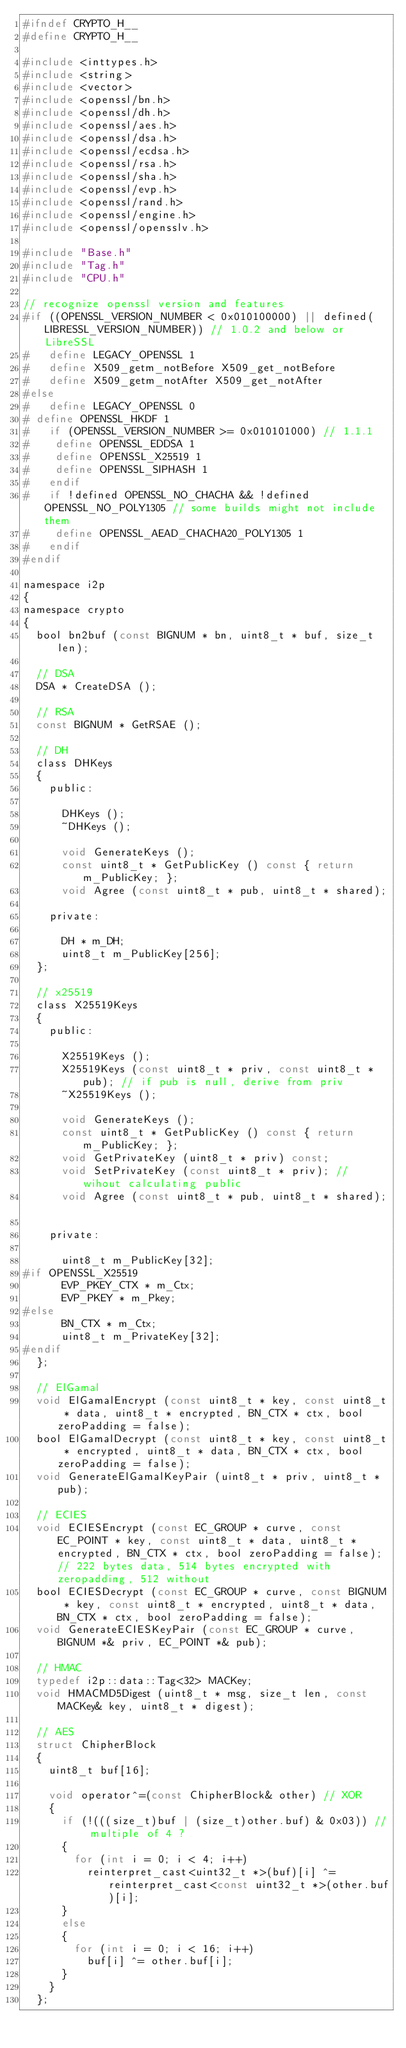Convert code to text. <code><loc_0><loc_0><loc_500><loc_500><_C_>#ifndef CRYPTO_H__
#define CRYPTO_H__

#include <inttypes.h>
#include <string>
#include <vector>
#include <openssl/bn.h>
#include <openssl/dh.h>
#include <openssl/aes.h>
#include <openssl/dsa.h>
#include <openssl/ecdsa.h>
#include <openssl/rsa.h>
#include <openssl/sha.h>
#include <openssl/evp.h>
#include <openssl/rand.h>
#include <openssl/engine.h>
#include <openssl/opensslv.h>

#include "Base.h"
#include "Tag.h"
#include "CPU.h"

// recognize openssl version and features
#if ((OPENSSL_VERSION_NUMBER < 0x010100000) || defined(LIBRESSL_VERSION_NUMBER)) // 1.0.2 and below or LibreSSL
#   define LEGACY_OPENSSL 1
#   define X509_getm_notBefore X509_get_notBefore
#   define X509_getm_notAfter X509_get_notAfter
#else
#   define LEGACY_OPENSSL 0
#	define OPENSSL_HKDF 1
#   if (OPENSSL_VERSION_NUMBER >= 0x010101000) // 1.1.1
#	   define OPENSSL_EDDSA 1
#	   define OPENSSL_X25519 1
#	   define OPENSSL_SIPHASH 1
#   endif
#   if !defined OPENSSL_NO_CHACHA && !defined OPENSSL_NO_POLY1305 // some builds might not include them
#	   define OPENSSL_AEAD_CHACHA20_POLY1305 1 
#   endif
#endif

namespace i2p
{
namespace crypto
{
	bool bn2buf (const BIGNUM * bn, uint8_t * buf, size_t len);

	// DSA
	DSA * CreateDSA ();

	// RSA
	const BIGNUM * GetRSAE ();

	// DH
	class DHKeys
	{
		public:

			DHKeys ();
			~DHKeys ();

			void GenerateKeys ();
			const uint8_t * GetPublicKey () const { return m_PublicKey; };
			void Agree (const uint8_t * pub, uint8_t * shared);

		private:

			DH * m_DH;
			uint8_t m_PublicKey[256];
	};

	// x25519
	class X25519Keys
	{
		public:

			X25519Keys ();
			X25519Keys (const uint8_t * priv, const uint8_t * pub); // if pub is null, derive from priv
			~X25519Keys ();

			void GenerateKeys ();
			const uint8_t * GetPublicKey () const { return m_PublicKey; };
			void GetPrivateKey (uint8_t * priv) const;
			void SetPrivateKey (const uint8_t * priv); // wihout calculating public
			void Agree (const uint8_t * pub, uint8_t * shared);			

		private:

			uint8_t m_PublicKey[32];		
#if OPENSSL_X25519
			EVP_PKEY_CTX * m_Ctx;
			EVP_PKEY * m_Pkey;
#else			
			BN_CTX * m_Ctx;
			uint8_t m_PrivateKey[32];
#endif			
	};
	
	// ElGamal
	void ElGamalEncrypt (const uint8_t * key, const uint8_t * data, uint8_t * encrypted, BN_CTX * ctx, bool zeroPadding = false);
	bool ElGamalDecrypt (const uint8_t * key, const uint8_t * encrypted, uint8_t * data, BN_CTX * ctx, bool zeroPadding = false);
	void GenerateElGamalKeyPair (uint8_t * priv, uint8_t * pub);

	// ECIES
	void ECIESEncrypt (const EC_GROUP * curve, const EC_POINT * key, const uint8_t * data, uint8_t * encrypted, BN_CTX * ctx, bool zeroPadding = false); // 222 bytes data, 514 bytes encrypted with zeropadding, 512 without
	bool ECIESDecrypt (const EC_GROUP * curve, const BIGNUM * key, const uint8_t * encrypted, uint8_t * data, BN_CTX * ctx, bool zeroPadding = false);
	void GenerateECIESKeyPair (const EC_GROUP * curve, BIGNUM *& priv, EC_POINT *& pub);

	// HMAC
	typedef i2p::data::Tag<32> MACKey;
	void HMACMD5Digest (uint8_t * msg, size_t len, const MACKey& key, uint8_t * digest);

	// AES
	struct ChipherBlock
	{
		uint8_t buf[16];

		void operator^=(const ChipherBlock& other) // XOR
		{
			if (!(((size_t)buf | (size_t)other.buf) & 0x03)) // multiple of 4 ?
			{	
				for (int i = 0; i < 4; i++)
					reinterpret_cast<uint32_t *>(buf)[i] ^= reinterpret_cast<const uint32_t *>(other.buf)[i];
			}	
			else
			{	
				for (int i = 0; i < 16; i++)
					buf[i] ^= other.buf[i];
			}					
		}
	};
</code> 